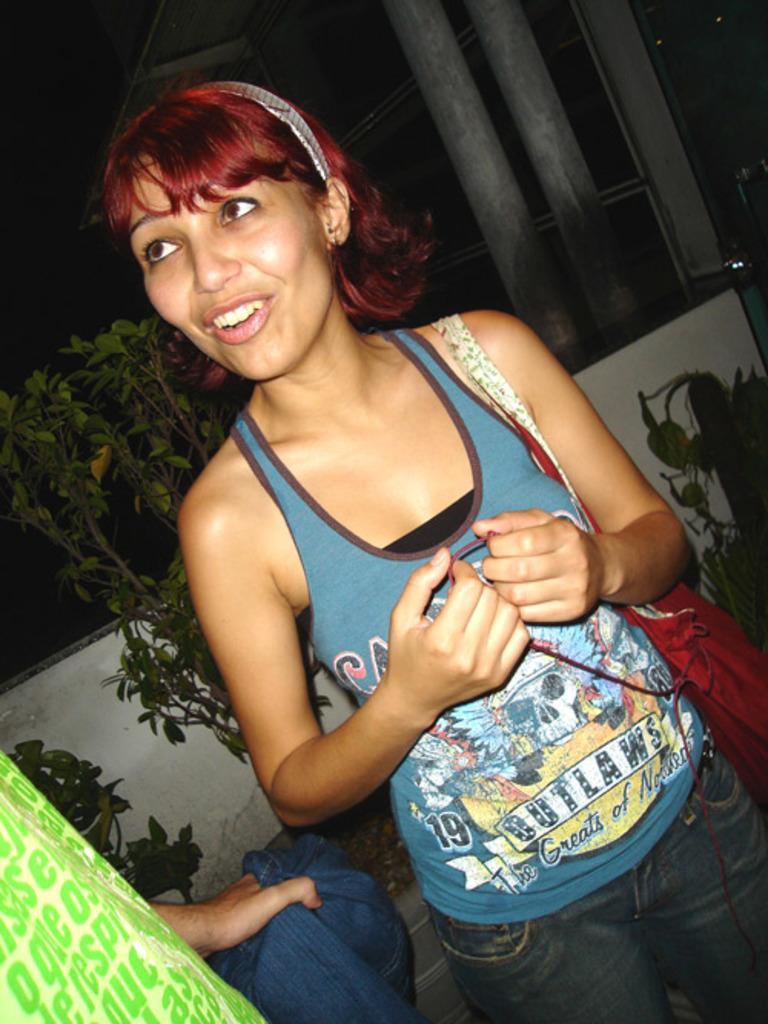Describe this image in one or two sentences. In this image we can see a woman with a smiling face and behind her we can see boundary wall and plants. 